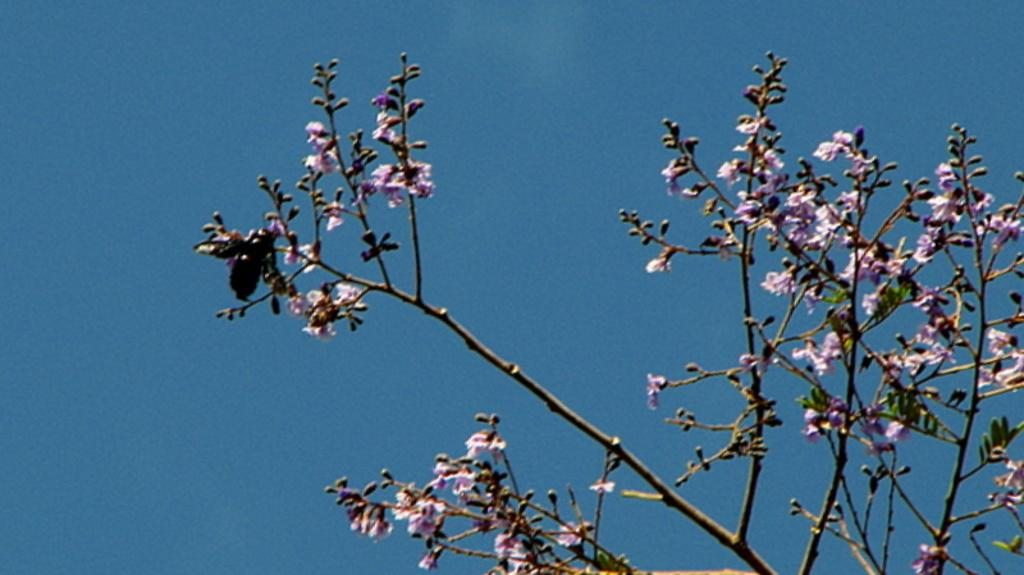What type of plant life can be seen in the image? There are branches and flowers in the image. Are there any living organisms visible in the image? Yes, there is an insect in the image. What can be seen in the background of the image? The sky is visible in the background of the image. What type of toothbrush is the insect using in the image? There is no toothbrush present in the image, and insects do not use toothbrushes. 